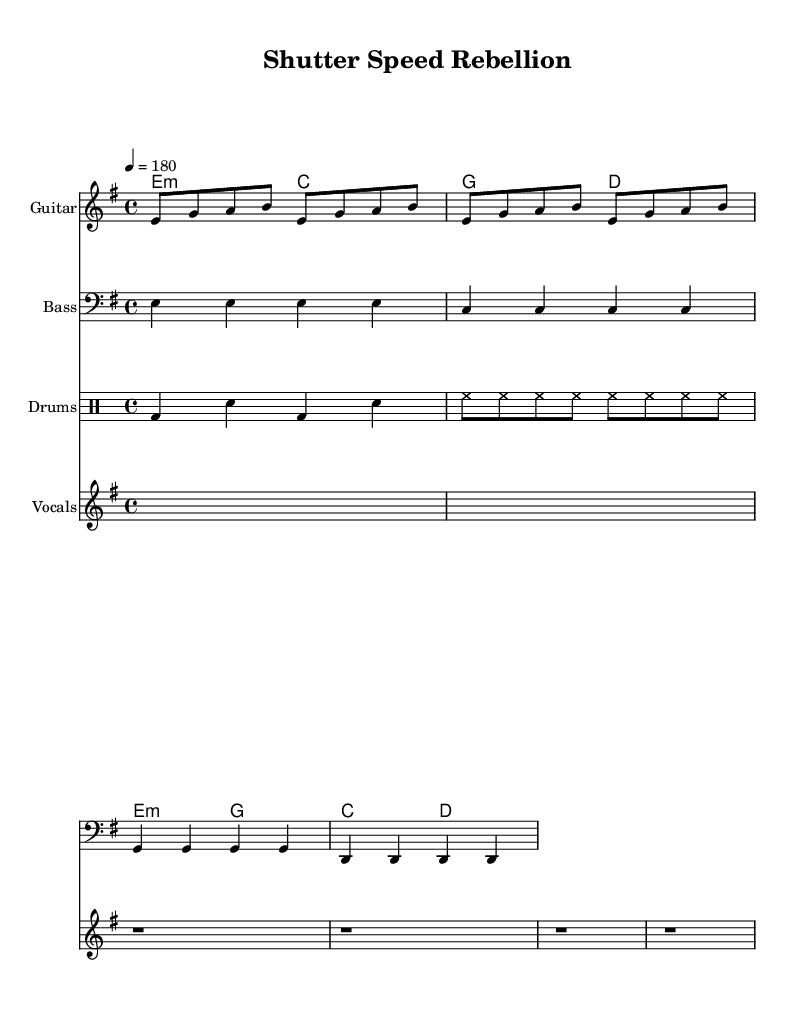What is the key signature of this music? The key signature is identified by looking at the beginning of the staff where sharp or flat symbols are located. In this sheet music, there are no sharps or flats shown, indicating that the key signature is E minor.
Answer: E minor What is the time signature of the piece? The time signature is located at the beginning of the sheet music, after the key signature. In this case, it is indicated as 4/4, meaning there are four beats in each measure and the quarter note gets one beat.
Answer: 4/4 What is the tempo marking of this music? The tempo marking can be found next to the time signature and indicates how fast the piece should be played. Here, it is shown as a quarter note equaling 180 beats per minute.
Answer: 180 How many measures are in the guitar riff section? To determine the number of measures, we count the vertical lines (bar lines) that separate the musical phrases. There are four measures in the guitar riff section.
Answer: 4 What are the primary instruments used in this sheet music? The instruments can be identified by looking at the titles provided for each staff. The primary instruments listed are Guitar, Bass, and Drums.
Answer: Guitar, Bass, Drums What is the lyrical theme expressed in the vocals? To analyze the lyrical theme, we read through the lyrics provided. The lyrics discuss the contrast between frozen moments and motion, suggesting a theme related to the fleeting essence of experiences versus static captures.
Answer: Motion vs. static lies What type of chords are primarily used in the chord progression? Observing the chord symbols provided in the chord section of the music, we note that the progression includes minor chords (E minor) and major chords (C major, G major). This mixture is commonly found in punk music for creating a raw, energetic sound.
Answer: Minor and Major chords 